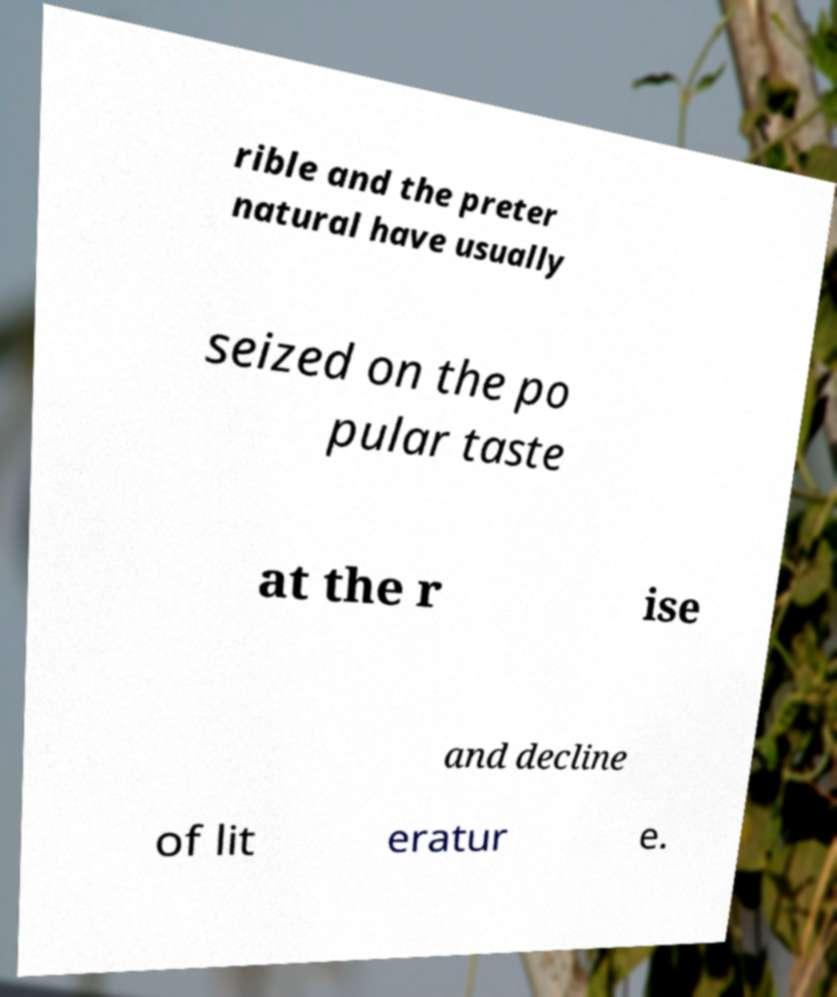Please read and relay the text visible in this image. What does it say? rible and the preter natural have usually seized on the po pular taste at the r ise and decline of lit eratur e. 